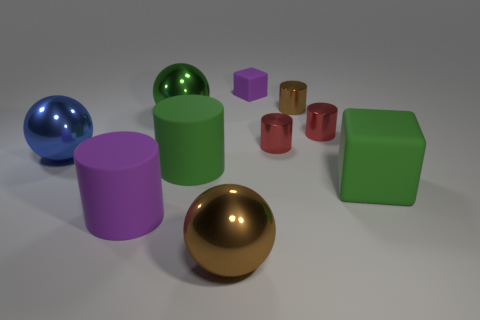Subtract 1 cylinders. How many cylinders are left? 4 Subtract all brown cylinders. How many cylinders are left? 4 Subtract all tiny brown cylinders. How many cylinders are left? 4 Subtract all gray cylinders. Subtract all cyan blocks. How many cylinders are left? 5 Subtract 1 brown spheres. How many objects are left? 9 Subtract all balls. How many objects are left? 7 Subtract all red metallic objects. Subtract all red shiny cylinders. How many objects are left? 6 Add 6 big metal objects. How many big metal objects are left? 9 Add 4 red shiny objects. How many red shiny objects exist? 6 